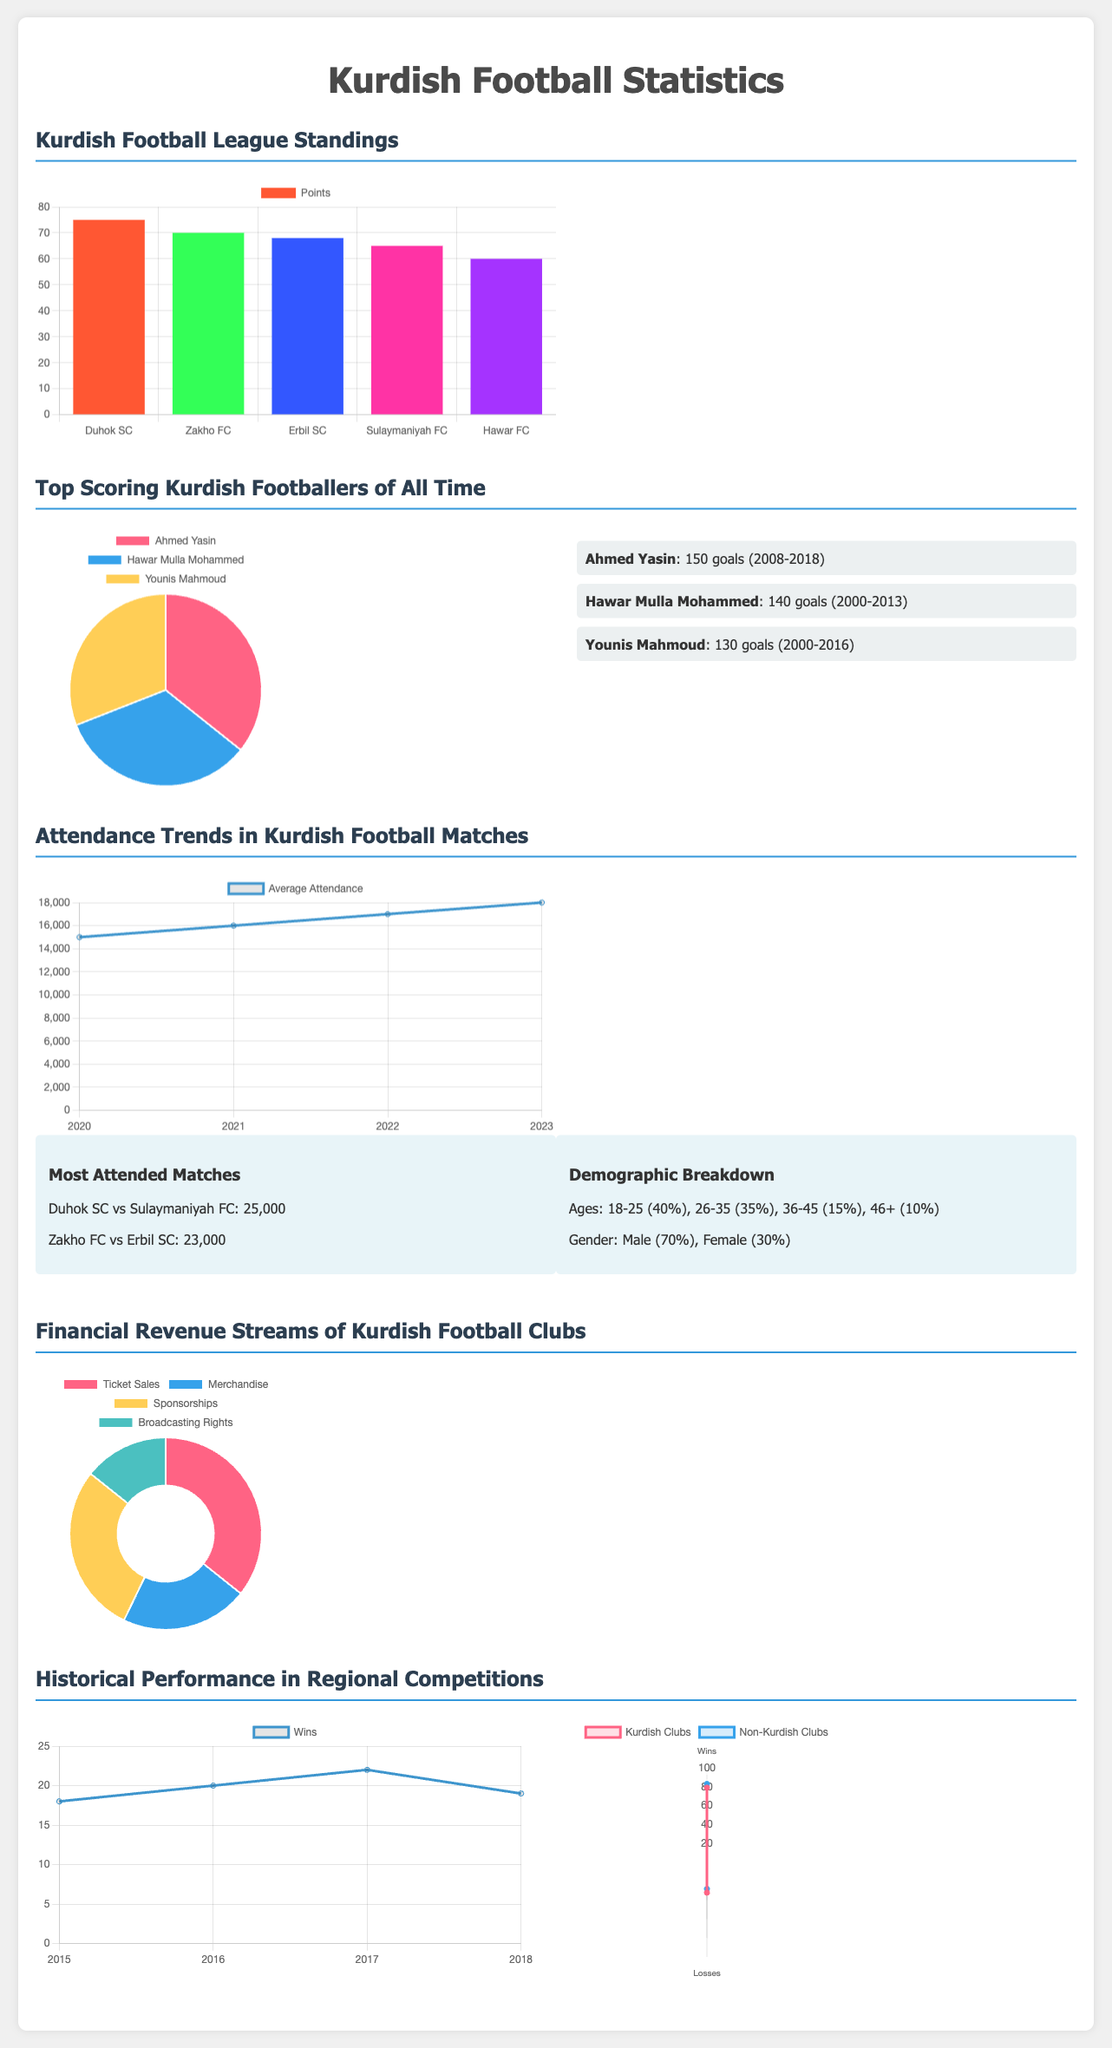What is the top team in the standings? The top team in the standings according to the bar chart is Duhok SC.
Answer: Duhok SC How many goals did Ahmed Yasin score? Ahmed Yasin scored a total of 150 goals as mentioned in the top scorers section.
Answer: 150 goals What was the average attendance in 2023? The average attendance in 2023 was 18000 based on the line graph data.
Answer: 18000 What percentage of attendance demographics are male? The demographic breakdown shows that 70% of attendees are male.
Answer: 70% Which club had the highest revenue from ticket sales? The document indicates that the highest revenue source is from ticket sales, which is $5000000.
Answer: $5000000 What is the win count for Kurdish clubs in the year 2018? The line graph for yearly performance shows that Kurdish clubs had 19 wins in 2018.
Answer: 19 Which Kurdish footballer has a career timeline from 2000 to 2013? The player with a career timeline from 2000 to 2013 is Hawar Mulla Mohammed.
Answer: Hawar Mulla Mohammed What is the total number of losses for non-Kurdish clubs? Based on the radar chart, non-Kurdish clubs had a total of 28 losses.
Answer: 28 Which club scored the most goals in the document? The document does not specify goals scored for each club, but it highlights standings and points.
Answer: Not applicable 